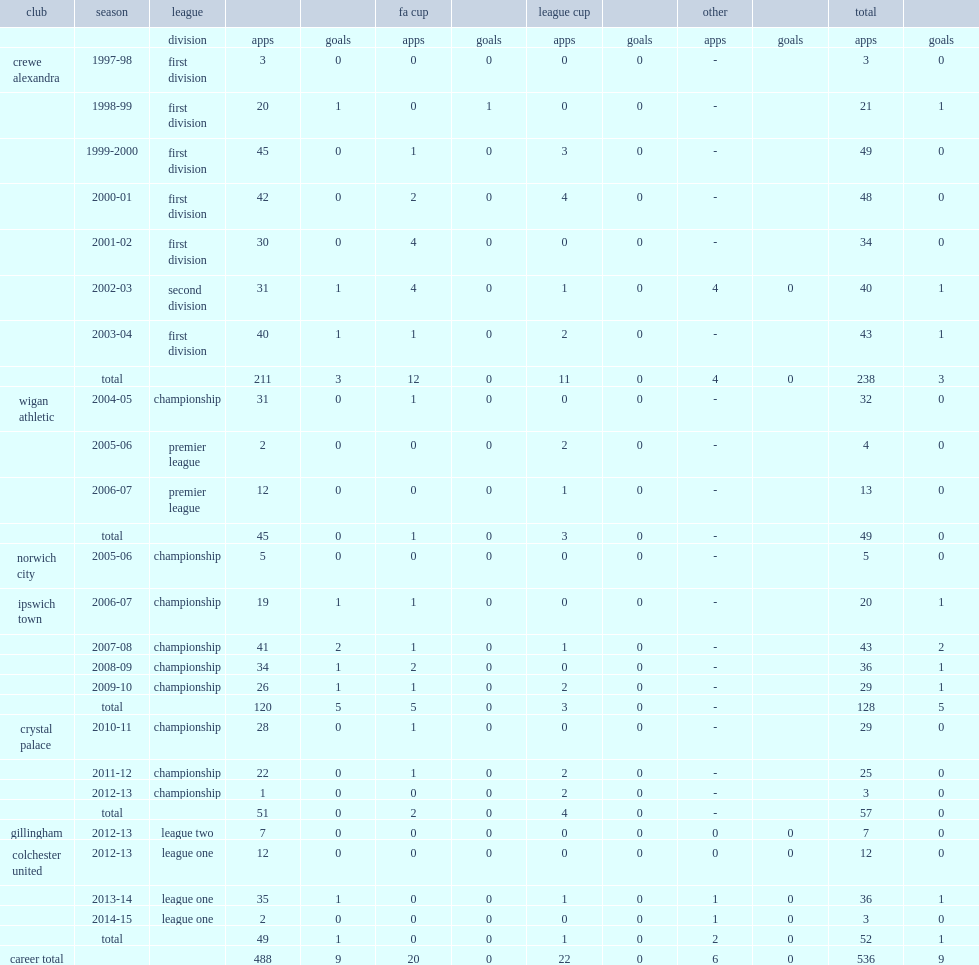How many matches did wright play for ipswich totally? 128.0. 